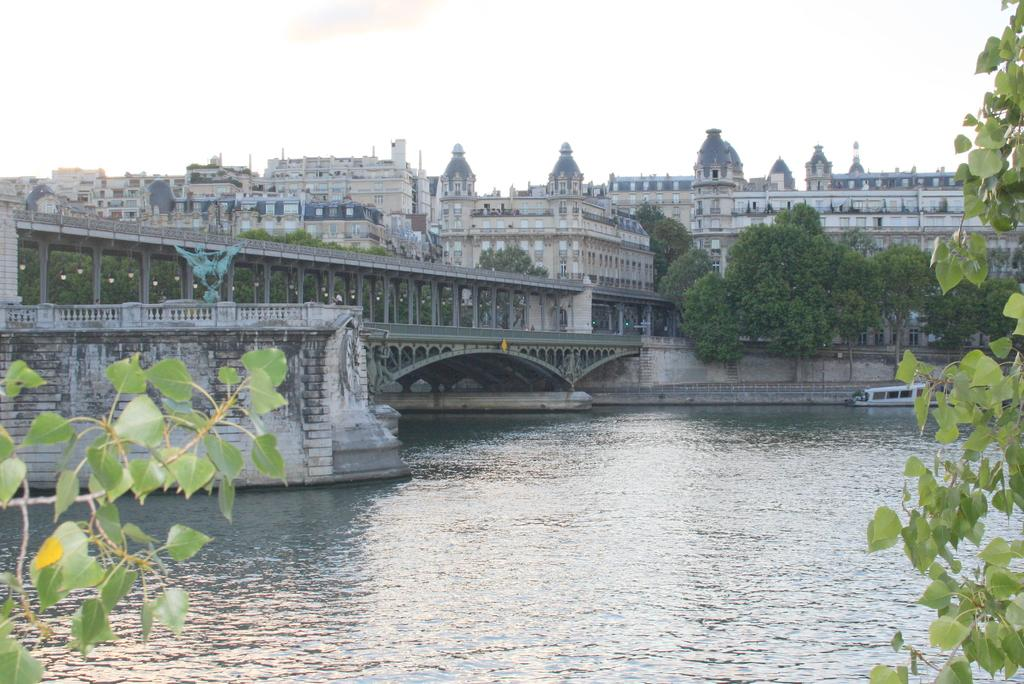What type of vegetation is present in the image? There are green leaves in the image. What man-made structure can be seen in the image? There is a bridge in the image. What type of watercraft is visible in the image? There is a boat in the image. What can be seen in the distance in the image? There are buildings and trees in the distance. What type of ring can be seen on the finger of the person in the boat? There is no person in the boat, nor is there any ring visible in the image. What type of flight is taking off from the bridge in the image? There is no flight or airplane present in the image; it only features a bridge, a boat, and green leaves. 